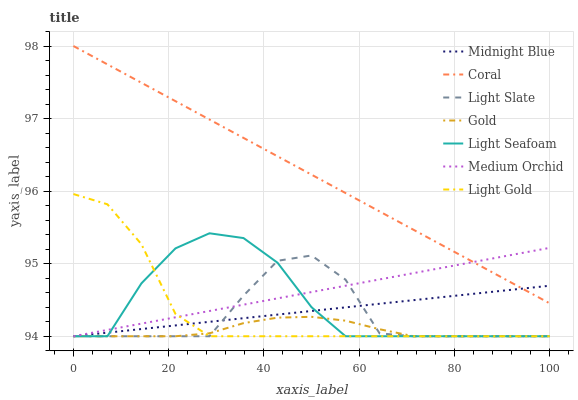Does Gold have the minimum area under the curve?
Answer yes or no. Yes. Does Coral have the maximum area under the curve?
Answer yes or no. Yes. Does Light Slate have the minimum area under the curve?
Answer yes or no. No. Does Light Slate have the maximum area under the curve?
Answer yes or no. No. Is Medium Orchid the smoothest?
Answer yes or no. Yes. Is Light Seafoam the roughest?
Answer yes or no. Yes. Is Gold the smoothest?
Answer yes or no. No. Is Gold the roughest?
Answer yes or no. No. Does Midnight Blue have the lowest value?
Answer yes or no. Yes. Does Coral have the lowest value?
Answer yes or no. No. Does Coral have the highest value?
Answer yes or no. Yes. Does Light Slate have the highest value?
Answer yes or no. No. Is Light Slate less than Coral?
Answer yes or no. Yes. Is Coral greater than Light Slate?
Answer yes or no. Yes. Does Midnight Blue intersect Coral?
Answer yes or no. Yes. Is Midnight Blue less than Coral?
Answer yes or no. No. Is Midnight Blue greater than Coral?
Answer yes or no. No. Does Light Slate intersect Coral?
Answer yes or no. No. 